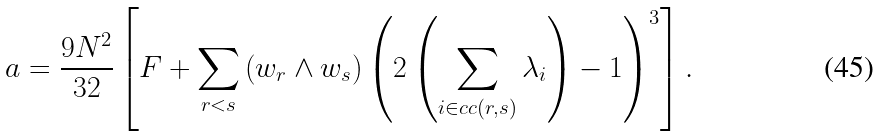Convert formula to latex. <formula><loc_0><loc_0><loc_500><loc_500>a = \frac { 9 N ^ { 2 } } { 3 2 } \left [ F + \sum _ { r < s } \left ( w _ { r } \wedge w _ { s } \right ) \left ( 2 \left ( \sum _ { i \in c c ( r , s ) } \lambda _ { i } \right ) - 1 \right ) ^ { 3 } \right ] .</formula> 